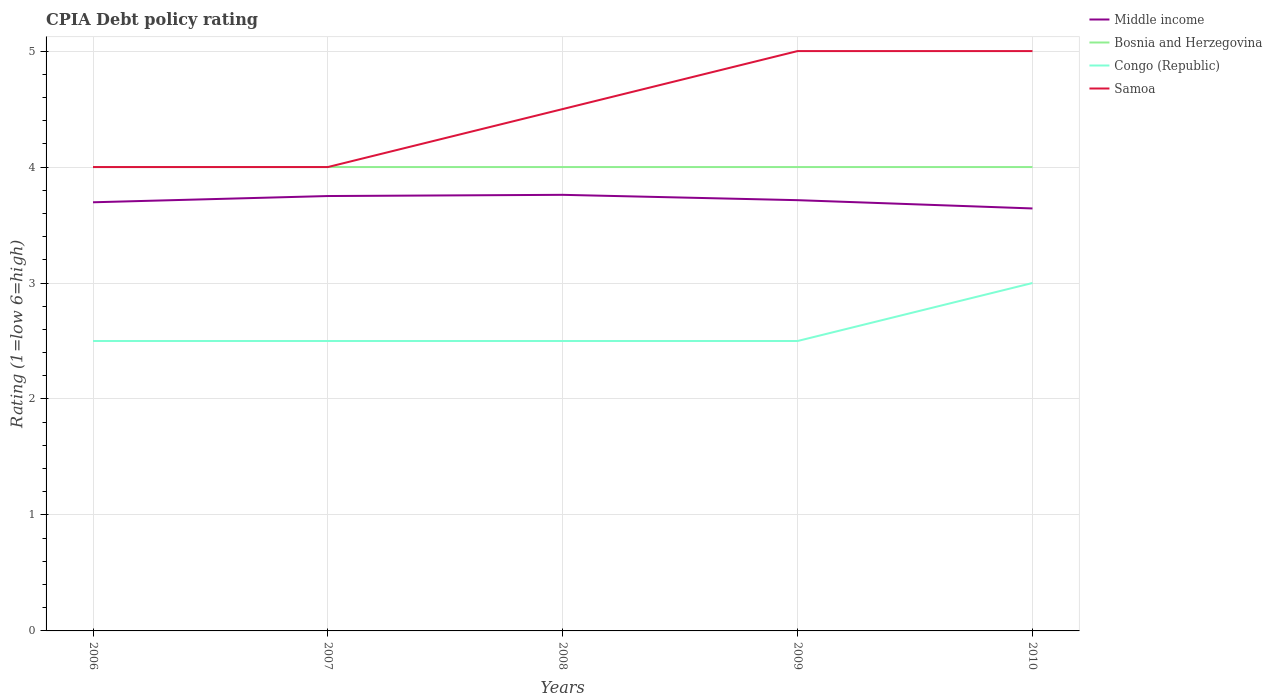Does the line corresponding to Congo (Republic) intersect with the line corresponding to Bosnia and Herzegovina?
Ensure brevity in your answer.  No. In which year was the CPIA rating in Samoa maximum?
Give a very brief answer. 2006. What is the total CPIA rating in Samoa in the graph?
Give a very brief answer. -0.5. What is the difference between the highest and the second highest CPIA rating in Bosnia and Herzegovina?
Your answer should be compact. 0. What is the difference between two consecutive major ticks on the Y-axis?
Your response must be concise. 1. Are the values on the major ticks of Y-axis written in scientific E-notation?
Offer a terse response. No. Does the graph contain any zero values?
Make the answer very short. No. Does the graph contain grids?
Offer a terse response. Yes. How many legend labels are there?
Your answer should be very brief. 4. What is the title of the graph?
Provide a short and direct response. CPIA Debt policy rating. What is the label or title of the Y-axis?
Your response must be concise. Rating (1=low 6=high). What is the Rating (1=low 6=high) in Middle income in 2006?
Provide a short and direct response. 3.7. What is the Rating (1=low 6=high) in Congo (Republic) in 2006?
Give a very brief answer. 2.5. What is the Rating (1=low 6=high) in Middle income in 2007?
Your answer should be very brief. 3.75. What is the Rating (1=low 6=high) of Bosnia and Herzegovina in 2007?
Your answer should be compact. 4. What is the Rating (1=low 6=high) of Samoa in 2007?
Make the answer very short. 4. What is the Rating (1=low 6=high) of Middle income in 2008?
Your response must be concise. 3.76. What is the Rating (1=low 6=high) of Bosnia and Herzegovina in 2008?
Your response must be concise. 4. What is the Rating (1=low 6=high) in Congo (Republic) in 2008?
Offer a terse response. 2.5. What is the Rating (1=low 6=high) of Samoa in 2008?
Keep it short and to the point. 4.5. What is the Rating (1=low 6=high) of Middle income in 2009?
Ensure brevity in your answer.  3.71. What is the Rating (1=low 6=high) in Bosnia and Herzegovina in 2009?
Provide a succinct answer. 4. What is the Rating (1=low 6=high) in Congo (Republic) in 2009?
Provide a short and direct response. 2.5. What is the Rating (1=low 6=high) in Middle income in 2010?
Make the answer very short. 3.64. Across all years, what is the maximum Rating (1=low 6=high) of Middle income?
Offer a terse response. 3.76. Across all years, what is the maximum Rating (1=low 6=high) of Bosnia and Herzegovina?
Offer a very short reply. 4. Across all years, what is the maximum Rating (1=low 6=high) of Congo (Republic)?
Give a very brief answer. 3. Across all years, what is the minimum Rating (1=low 6=high) in Middle income?
Make the answer very short. 3.64. Across all years, what is the minimum Rating (1=low 6=high) in Samoa?
Make the answer very short. 4. What is the total Rating (1=low 6=high) of Middle income in the graph?
Make the answer very short. 18.56. What is the total Rating (1=low 6=high) of Samoa in the graph?
Your response must be concise. 22.5. What is the difference between the Rating (1=low 6=high) in Middle income in 2006 and that in 2007?
Offer a very short reply. -0.05. What is the difference between the Rating (1=low 6=high) in Middle income in 2006 and that in 2008?
Provide a succinct answer. -0.06. What is the difference between the Rating (1=low 6=high) of Congo (Republic) in 2006 and that in 2008?
Provide a short and direct response. 0. What is the difference between the Rating (1=low 6=high) of Samoa in 2006 and that in 2008?
Your response must be concise. -0.5. What is the difference between the Rating (1=low 6=high) in Middle income in 2006 and that in 2009?
Provide a succinct answer. -0.02. What is the difference between the Rating (1=low 6=high) in Congo (Republic) in 2006 and that in 2009?
Offer a very short reply. 0. What is the difference between the Rating (1=low 6=high) of Middle income in 2006 and that in 2010?
Your answer should be very brief. 0.05. What is the difference between the Rating (1=low 6=high) of Bosnia and Herzegovina in 2006 and that in 2010?
Keep it short and to the point. 0. What is the difference between the Rating (1=low 6=high) of Samoa in 2006 and that in 2010?
Offer a terse response. -1. What is the difference between the Rating (1=low 6=high) in Middle income in 2007 and that in 2008?
Offer a terse response. -0.01. What is the difference between the Rating (1=low 6=high) of Middle income in 2007 and that in 2009?
Your answer should be compact. 0.04. What is the difference between the Rating (1=low 6=high) of Congo (Republic) in 2007 and that in 2009?
Make the answer very short. 0. What is the difference between the Rating (1=low 6=high) in Samoa in 2007 and that in 2009?
Your response must be concise. -1. What is the difference between the Rating (1=low 6=high) in Middle income in 2007 and that in 2010?
Your answer should be compact. 0.11. What is the difference between the Rating (1=low 6=high) in Bosnia and Herzegovina in 2007 and that in 2010?
Offer a very short reply. 0. What is the difference between the Rating (1=low 6=high) of Congo (Republic) in 2007 and that in 2010?
Ensure brevity in your answer.  -0.5. What is the difference between the Rating (1=low 6=high) of Middle income in 2008 and that in 2009?
Offer a terse response. 0.05. What is the difference between the Rating (1=low 6=high) in Bosnia and Herzegovina in 2008 and that in 2009?
Ensure brevity in your answer.  0. What is the difference between the Rating (1=low 6=high) in Middle income in 2008 and that in 2010?
Offer a terse response. 0.12. What is the difference between the Rating (1=low 6=high) of Bosnia and Herzegovina in 2008 and that in 2010?
Make the answer very short. 0. What is the difference between the Rating (1=low 6=high) in Congo (Republic) in 2008 and that in 2010?
Offer a very short reply. -0.5. What is the difference between the Rating (1=low 6=high) of Samoa in 2008 and that in 2010?
Offer a very short reply. -0.5. What is the difference between the Rating (1=low 6=high) in Middle income in 2009 and that in 2010?
Your answer should be compact. 0.07. What is the difference between the Rating (1=low 6=high) in Samoa in 2009 and that in 2010?
Offer a very short reply. 0. What is the difference between the Rating (1=low 6=high) of Middle income in 2006 and the Rating (1=low 6=high) of Bosnia and Herzegovina in 2007?
Ensure brevity in your answer.  -0.3. What is the difference between the Rating (1=low 6=high) of Middle income in 2006 and the Rating (1=low 6=high) of Congo (Republic) in 2007?
Your response must be concise. 1.2. What is the difference between the Rating (1=low 6=high) in Middle income in 2006 and the Rating (1=low 6=high) in Samoa in 2007?
Offer a terse response. -0.3. What is the difference between the Rating (1=low 6=high) in Bosnia and Herzegovina in 2006 and the Rating (1=low 6=high) in Congo (Republic) in 2007?
Ensure brevity in your answer.  1.5. What is the difference between the Rating (1=low 6=high) in Bosnia and Herzegovina in 2006 and the Rating (1=low 6=high) in Samoa in 2007?
Provide a succinct answer. 0. What is the difference between the Rating (1=low 6=high) of Congo (Republic) in 2006 and the Rating (1=low 6=high) of Samoa in 2007?
Provide a succinct answer. -1.5. What is the difference between the Rating (1=low 6=high) in Middle income in 2006 and the Rating (1=low 6=high) in Bosnia and Herzegovina in 2008?
Give a very brief answer. -0.3. What is the difference between the Rating (1=low 6=high) in Middle income in 2006 and the Rating (1=low 6=high) in Congo (Republic) in 2008?
Your answer should be very brief. 1.2. What is the difference between the Rating (1=low 6=high) of Middle income in 2006 and the Rating (1=low 6=high) of Samoa in 2008?
Keep it short and to the point. -0.8. What is the difference between the Rating (1=low 6=high) of Bosnia and Herzegovina in 2006 and the Rating (1=low 6=high) of Samoa in 2008?
Offer a very short reply. -0.5. What is the difference between the Rating (1=low 6=high) of Congo (Republic) in 2006 and the Rating (1=low 6=high) of Samoa in 2008?
Provide a succinct answer. -2. What is the difference between the Rating (1=low 6=high) in Middle income in 2006 and the Rating (1=low 6=high) in Bosnia and Herzegovina in 2009?
Your answer should be very brief. -0.3. What is the difference between the Rating (1=low 6=high) of Middle income in 2006 and the Rating (1=low 6=high) of Congo (Republic) in 2009?
Provide a succinct answer. 1.2. What is the difference between the Rating (1=low 6=high) of Middle income in 2006 and the Rating (1=low 6=high) of Samoa in 2009?
Give a very brief answer. -1.3. What is the difference between the Rating (1=low 6=high) in Bosnia and Herzegovina in 2006 and the Rating (1=low 6=high) in Congo (Republic) in 2009?
Keep it short and to the point. 1.5. What is the difference between the Rating (1=low 6=high) of Middle income in 2006 and the Rating (1=low 6=high) of Bosnia and Herzegovina in 2010?
Offer a very short reply. -0.3. What is the difference between the Rating (1=low 6=high) in Middle income in 2006 and the Rating (1=low 6=high) in Congo (Republic) in 2010?
Make the answer very short. 0.7. What is the difference between the Rating (1=low 6=high) of Middle income in 2006 and the Rating (1=low 6=high) of Samoa in 2010?
Your response must be concise. -1.3. What is the difference between the Rating (1=low 6=high) of Bosnia and Herzegovina in 2006 and the Rating (1=low 6=high) of Congo (Republic) in 2010?
Ensure brevity in your answer.  1. What is the difference between the Rating (1=low 6=high) of Congo (Republic) in 2006 and the Rating (1=low 6=high) of Samoa in 2010?
Ensure brevity in your answer.  -2.5. What is the difference between the Rating (1=low 6=high) of Middle income in 2007 and the Rating (1=low 6=high) of Bosnia and Herzegovina in 2008?
Provide a succinct answer. -0.25. What is the difference between the Rating (1=low 6=high) in Middle income in 2007 and the Rating (1=low 6=high) in Samoa in 2008?
Make the answer very short. -0.75. What is the difference between the Rating (1=low 6=high) in Middle income in 2007 and the Rating (1=low 6=high) in Bosnia and Herzegovina in 2009?
Provide a succinct answer. -0.25. What is the difference between the Rating (1=low 6=high) in Middle income in 2007 and the Rating (1=low 6=high) in Congo (Republic) in 2009?
Offer a terse response. 1.25. What is the difference between the Rating (1=low 6=high) in Middle income in 2007 and the Rating (1=low 6=high) in Samoa in 2009?
Provide a short and direct response. -1.25. What is the difference between the Rating (1=low 6=high) of Bosnia and Herzegovina in 2007 and the Rating (1=low 6=high) of Congo (Republic) in 2009?
Ensure brevity in your answer.  1.5. What is the difference between the Rating (1=low 6=high) of Congo (Republic) in 2007 and the Rating (1=low 6=high) of Samoa in 2009?
Your response must be concise. -2.5. What is the difference between the Rating (1=low 6=high) of Middle income in 2007 and the Rating (1=low 6=high) of Congo (Republic) in 2010?
Make the answer very short. 0.75. What is the difference between the Rating (1=low 6=high) of Middle income in 2007 and the Rating (1=low 6=high) of Samoa in 2010?
Give a very brief answer. -1.25. What is the difference between the Rating (1=low 6=high) of Bosnia and Herzegovina in 2007 and the Rating (1=low 6=high) of Congo (Republic) in 2010?
Keep it short and to the point. 1. What is the difference between the Rating (1=low 6=high) in Bosnia and Herzegovina in 2007 and the Rating (1=low 6=high) in Samoa in 2010?
Your answer should be compact. -1. What is the difference between the Rating (1=low 6=high) of Congo (Republic) in 2007 and the Rating (1=low 6=high) of Samoa in 2010?
Your response must be concise. -2.5. What is the difference between the Rating (1=low 6=high) of Middle income in 2008 and the Rating (1=low 6=high) of Bosnia and Herzegovina in 2009?
Offer a terse response. -0.24. What is the difference between the Rating (1=low 6=high) of Middle income in 2008 and the Rating (1=low 6=high) of Congo (Republic) in 2009?
Keep it short and to the point. 1.26. What is the difference between the Rating (1=low 6=high) of Middle income in 2008 and the Rating (1=low 6=high) of Samoa in 2009?
Offer a very short reply. -1.24. What is the difference between the Rating (1=low 6=high) in Congo (Republic) in 2008 and the Rating (1=low 6=high) in Samoa in 2009?
Give a very brief answer. -2.5. What is the difference between the Rating (1=low 6=high) in Middle income in 2008 and the Rating (1=low 6=high) in Bosnia and Herzegovina in 2010?
Offer a very short reply. -0.24. What is the difference between the Rating (1=low 6=high) of Middle income in 2008 and the Rating (1=low 6=high) of Congo (Republic) in 2010?
Offer a very short reply. 0.76. What is the difference between the Rating (1=low 6=high) of Middle income in 2008 and the Rating (1=low 6=high) of Samoa in 2010?
Ensure brevity in your answer.  -1.24. What is the difference between the Rating (1=low 6=high) of Bosnia and Herzegovina in 2008 and the Rating (1=low 6=high) of Samoa in 2010?
Offer a very short reply. -1. What is the difference between the Rating (1=low 6=high) of Middle income in 2009 and the Rating (1=low 6=high) of Bosnia and Herzegovina in 2010?
Ensure brevity in your answer.  -0.29. What is the difference between the Rating (1=low 6=high) of Middle income in 2009 and the Rating (1=low 6=high) of Congo (Republic) in 2010?
Your answer should be very brief. 0.71. What is the difference between the Rating (1=low 6=high) of Middle income in 2009 and the Rating (1=low 6=high) of Samoa in 2010?
Make the answer very short. -1.29. What is the average Rating (1=low 6=high) of Middle income per year?
Your response must be concise. 3.71. What is the average Rating (1=low 6=high) in Congo (Republic) per year?
Offer a terse response. 2.6. What is the average Rating (1=low 6=high) of Samoa per year?
Ensure brevity in your answer.  4.5. In the year 2006, what is the difference between the Rating (1=low 6=high) in Middle income and Rating (1=low 6=high) in Bosnia and Herzegovina?
Your response must be concise. -0.3. In the year 2006, what is the difference between the Rating (1=low 6=high) of Middle income and Rating (1=low 6=high) of Congo (Republic)?
Your answer should be compact. 1.2. In the year 2006, what is the difference between the Rating (1=low 6=high) in Middle income and Rating (1=low 6=high) in Samoa?
Your answer should be compact. -0.3. In the year 2006, what is the difference between the Rating (1=low 6=high) in Congo (Republic) and Rating (1=low 6=high) in Samoa?
Offer a very short reply. -1.5. In the year 2007, what is the difference between the Rating (1=low 6=high) of Middle income and Rating (1=low 6=high) of Bosnia and Herzegovina?
Keep it short and to the point. -0.25. In the year 2007, what is the difference between the Rating (1=low 6=high) in Middle income and Rating (1=low 6=high) in Congo (Republic)?
Make the answer very short. 1.25. In the year 2007, what is the difference between the Rating (1=low 6=high) of Bosnia and Herzegovina and Rating (1=low 6=high) of Congo (Republic)?
Provide a succinct answer. 1.5. In the year 2007, what is the difference between the Rating (1=low 6=high) of Bosnia and Herzegovina and Rating (1=low 6=high) of Samoa?
Offer a very short reply. 0. In the year 2007, what is the difference between the Rating (1=low 6=high) of Congo (Republic) and Rating (1=low 6=high) of Samoa?
Ensure brevity in your answer.  -1.5. In the year 2008, what is the difference between the Rating (1=low 6=high) of Middle income and Rating (1=low 6=high) of Bosnia and Herzegovina?
Provide a succinct answer. -0.24. In the year 2008, what is the difference between the Rating (1=low 6=high) in Middle income and Rating (1=low 6=high) in Congo (Republic)?
Your answer should be compact. 1.26. In the year 2008, what is the difference between the Rating (1=low 6=high) in Middle income and Rating (1=low 6=high) in Samoa?
Keep it short and to the point. -0.74. In the year 2009, what is the difference between the Rating (1=low 6=high) in Middle income and Rating (1=low 6=high) in Bosnia and Herzegovina?
Give a very brief answer. -0.29. In the year 2009, what is the difference between the Rating (1=low 6=high) of Middle income and Rating (1=low 6=high) of Congo (Republic)?
Offer a terse response. 1.21. In the year 2009, what is the difference between the Rating (1=low 6=high) in Middle income and Rating (1=low 6=high) in Samoa?
Offer a terse response. -1.29. In the year 2009, what is the difference between the Rating (1=low 6=high) in Bosnia and Herzegovina and Rating (1=low 6=high) in Samoa?
Keep it short and to the point. -1. In the year 2010, what is the difference between the Rating (1=low 6=high) of Middle income and Rating (1=low 6=high) of Bosnia and Herzegovina?
Ensure brevity in your answer.  -0.36. In the year 2010, what is the difference between the Rating (1=low 6=high) in Middle income and Rating (1=low 6=high) in Congo (Republic)?
Provide a succinct answer. 0.64. In the year 2010, what is the difference between the Rating (1=low 6=high) of Middle income and Rating (1=low 6=high) of Samoa?
Your response must be concise. -1.36. In the year 2010, what is the difference between the Rating (1=low 6=high) of Bosnia and Herzegovina and Rating (1=low 6=high) of Samoa?
Give a very brief answer. -1. In the year 2010, what is the difference between the Rating (1=low 6=high) of Congo (Republic) and Rating (1=low 6=high) of Samoa?
Provide a short and direct response. -2. What is the ratio of the Rating (1=low 6=high) of Middle income in 2006 to that in 2007?
Provide a succinct answer. 0.99. What is the ratio of the Rating (1=low 6=high) of Samoa in 2006 to that in 2007?
Make the answer very short. 1. What is the ratio of the Rating (1=low 6=high) in Middle income in 2006 to that in 2008?
Offer a very short reply. 0.98. What is the ratio of the Rating (1=low 6=high) in Samoa in 2006 to that in 2008?
Provide a succinct answer. 0.89. What is the ratio of the Rating (1=low 6=high) of Congo (Republic) in 2006 to that in 2009?
Your answer should be very brief. 1. What is the ratio of the Rating (1=low 6=high) in Middle income in 2006 to that in 2010?
Keep it short and to the point. 1.01. What is the ratio of the Rating (1=low 6=high) of Congo (Republic) in 2006 to that in 2010?
Your answer should be very brief. 0.83. What is the ratio of the Rating (1=low 6=high) in Bosnia and Herzegovina in 2007 to that in 2008?
Your response must be concise. 1. What is the ratio of the Rating (1=low 6=high) of Congo (Republic) in 2007 to that in 2008?
Keep it short and to the point. 1. What is the ratio of the Rating (1=low 6=high) in Samoa in 2007 to that in 2008?
Make the answer very short. 0.89. What is the ratio of the Rating (1=low 6=high) of Middle income in 2007 to that in 2009?
Offer a terse response. 1.01. What is the ratio of the Rating (1=low 6=high) of Middle income in 2007 to that in 2010?
Your response must be concise. 1.03. What is the ratio of the Rating (1=low 6=high) in Bosnia and Herzegovina in 2007 to that in 2010?
Offer a very short reply. 1. What is the ratio of the Rating (1=low 6=high) in Congo (Republic) in 2007 to that in 2010?
Provide a short and direct response. 0.83. What is the ratio of the Rating (1=low 6=high) in Samoa in 2007 to that in 2010?
Provide a short and direct response. 0.8. What is the ratio of the Rating (1=low 6=high) in Middle income in 2008 to that in 2009?
Offer a very short reply. 1.01. What is the ratio of the Rating (1=low 6=high) of Congo (Republic) in 2008 to that in 2009?
Provide a succinct answer. 1. What is the ratio of the Rating (1=low 6=high) of Samoa in 2008 to that in 2009?
Your answer should be very brief. 0.9. What is the ratio of the Rating (1=low 6=high) of Middle income in 2008 to that in 2010?
Provide a succinct answer. 1.03. What is the ratio of the Rating (1=low 6=high) of Congo (Republic) in 2008 to that in 2010?
Give a very brief answer. 0.83. What is the ratio of the Rating (1=low 6=high) in Middle income in 2009 to that in 2010?
Ensure brevity in your answer.  1.02. What is the ratio of the Rating (1=low 6=high) in Congo (Republic) in 2009 to that in 2010?
Your answer should be very brief. 0.83. What is the difference between the highest and the second highest Rating (1=low 6=high) of Middle income?
Your answer should be very brief. 0.01. What is the difference between the highest and the second highest Rating (1=low 6=high) of Congo (Republic)?
Provide a succinct answer. 0.5. What is the difference between the highest and the second highest Rating (1=low 6=high) in Samoa?
Your response must be concise. 0. What is the difference between the highest and the lowest Rating (1=low 6=high) in Middle income?
Your answer should be compact. 0.12. What is the difference between the highest and the lowest Rating (1=low 6=high) in Congo (Republic)?
Keep it short and to the point. 0.5. 